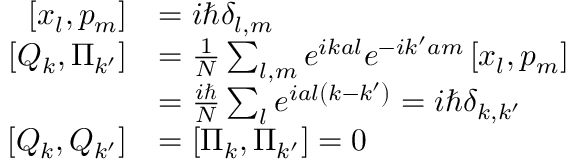<formula> <loc_0><loc_0><loc_500><loc_500>{ \begin{array} { r l } { \left [ x _ { l } , p _ { m } \right ] } & { = i \hbar { \delta } _ { l , m } } \\ { \left [ Q _ { k } , \Pi _ { k ^ { \prime } } \right ] } & { = { \frac { 1 } { N } } \sum _ { l , m } e ^ { i k a l } e ^ { - i k ^ { \prime } a m } \left [ x _ { l } , p _ { m } \right ] } \\ & { = { \frac { i } { N } } \sum _ { l } e ^ { i a l \left ( k - k ^ { \prime } \right ) } = i \hbar { \delta } _ { k , k ^ { \prime } } } \\ { \left [ Q _ { k } , Q _ { k ^ { \prime } } \right ] } & { = \left [ \Pi _ { k } , \Pi _ { k ^ { \prime } } \right ] = 0 } \end{array} }</formula> 